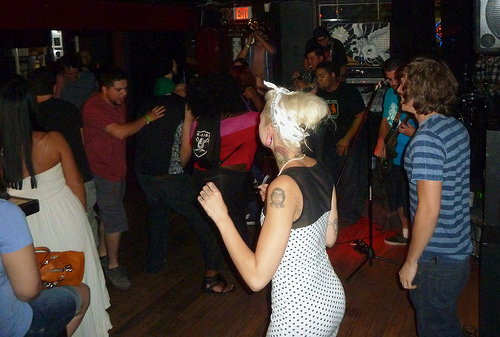<image>
Is the man in front of the lady? No. The man is not in front of the lady. The spatial positioning shows a different relationship between these objects. 